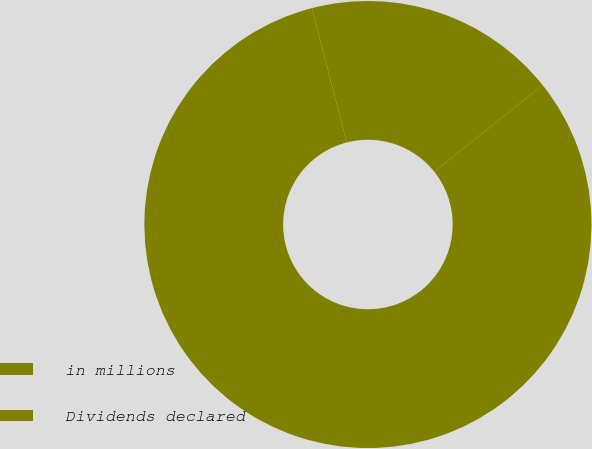<chart> <loc_0><loc_0><loc_500><loc_500><pie_chart><fcel>in millions<fcel>Dividends declared<nl><fcel>81.68%<fcel>18.32%<nl></chart> 